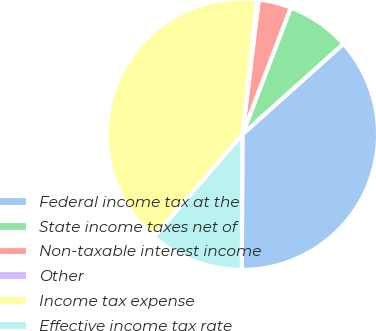Convert chart to OTSL. <chart><loc_0><loc_0><loc_500><loc_500><pie_chart><fcel>Federal income tax at the<fcel>State income taxes net of<fcel>Non-taxable interest income<fcel>Other<fcel>Income tax expense<fcel>Effective income tax rate<nl><fcel>36.7%<fcel>7.57%<fcel>3.89%<fcel>0.22%<fcel>40.37%<fcel>11.25%<nl></chart> 